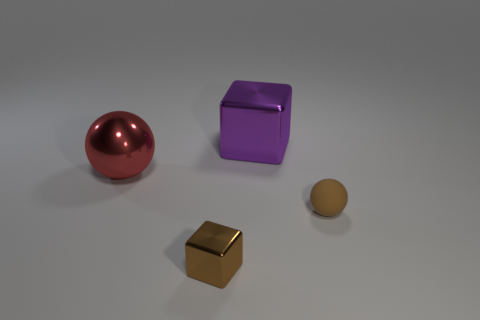Is there anything else that has the same material as the tiny sphere?
Give a very brief answer. No. Are there an equal number of large metal balls behind the purple metal thing and small brown matte things?
Offer a terse response. No. Do the brown cube and the red thing have the same size?
Make the answer very short. No. What is the color of the metallic object that is on the right side of the red object and behind the matte ball?
Your answer should be very brief. Purple. The large thing that is on the left side of the cube in front of the big red ball is made of what material?
Offer a terse response. Metal. What size is the metal thing that is the same shape as the small brown matte object?
Provide a short and direct response. Large. Do the tiny thing to the right of the large metallic block and the big cube have the same color?
Your answer should be very brief. No. Is the number of big shiny things less than the number of shiny things?
Give a very brief answer. Yes. What number of other objects are there of the same color as the small metallic block?
Your answer should be very brief. 1. Are the ball that is on the left side of the small brown metal thing and the big purple block made of the same material?
Provide a succinct answer. Yes. 